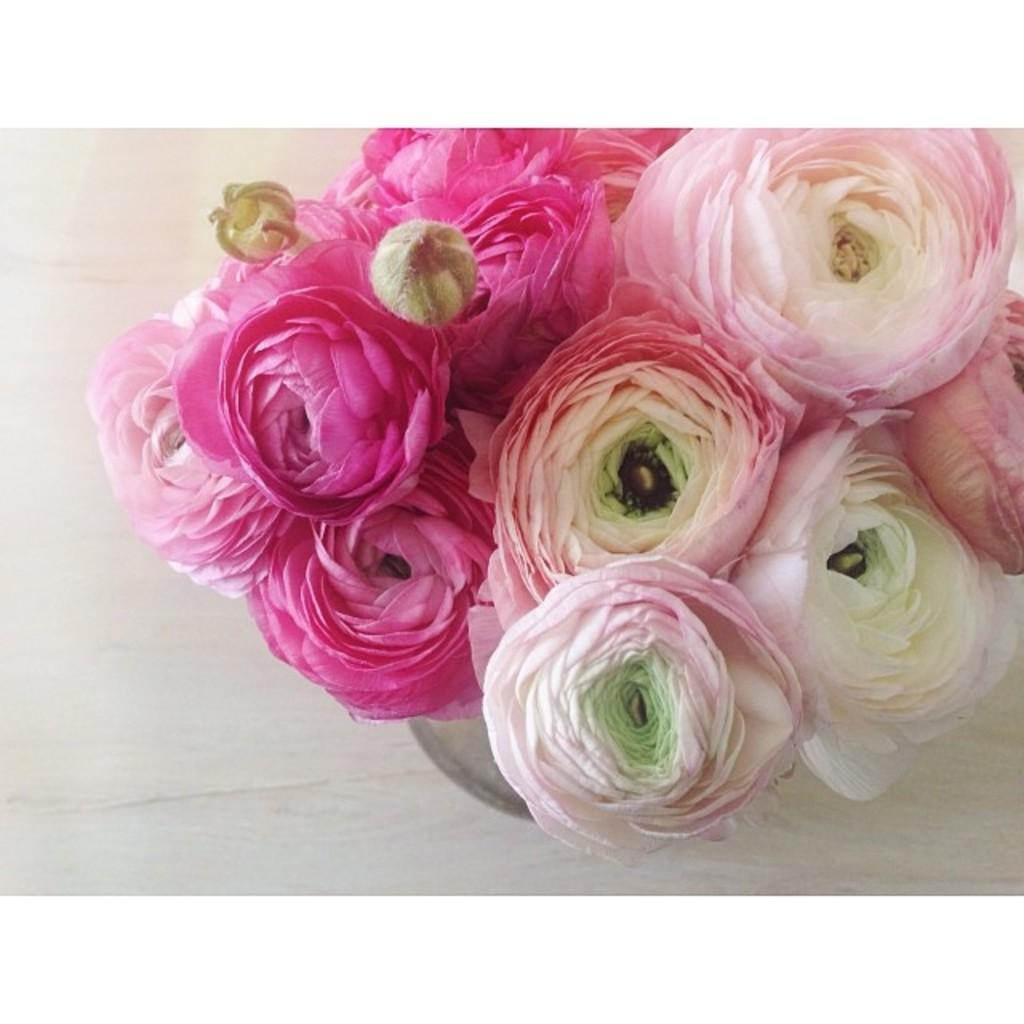What colors are the flowers in the image? The flowers in the image are pink and white. How might the flowers be arranged or displayed in the image? The flowers are likely kept in a vase. What is visible at the bottom of the image? There is a floor visible at the bottom of the image. Can you see a nest in the image? There is no nest present in the image. What direction are the flowers facing in the image? The flowers' orientation cannot be determined from the image, as we cannot see the direction they are facing. 